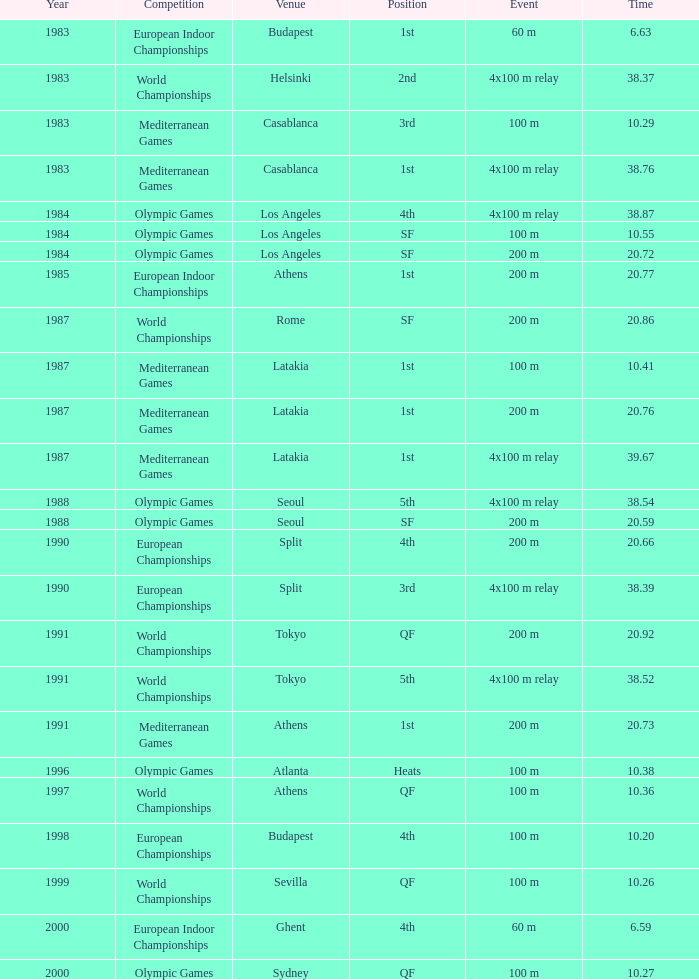What is the greatest Time with a Year of 1991, and Event of 4x100 m relay? 38.52. 